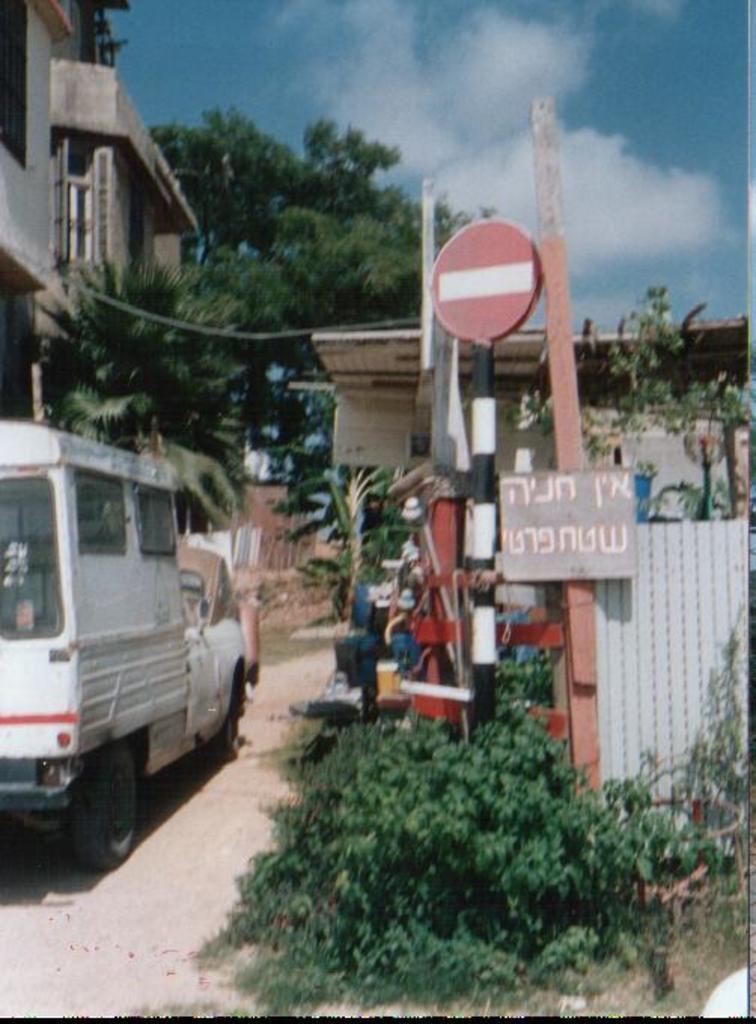How would you summarize this image in a sentence or two? In the image we can see a vehicle on the road. This is a pole, board, plant, grass, tree, building and a cloudy sky. 